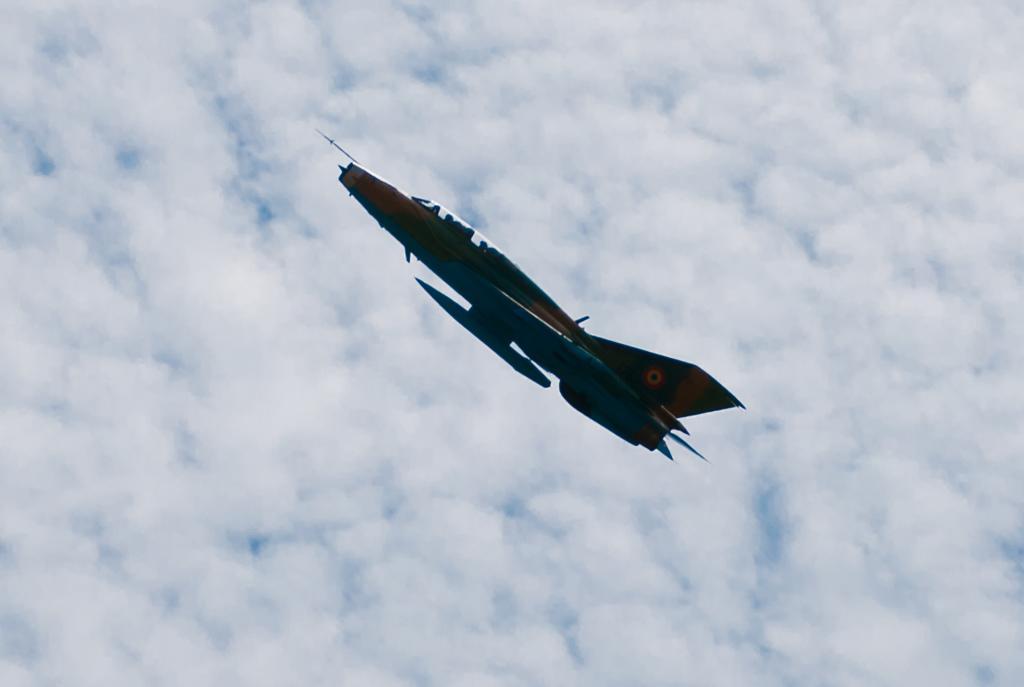Please provide a concise description of this image. In this image we can see a plane is flying in the air. In the background there is sky with clouds. 